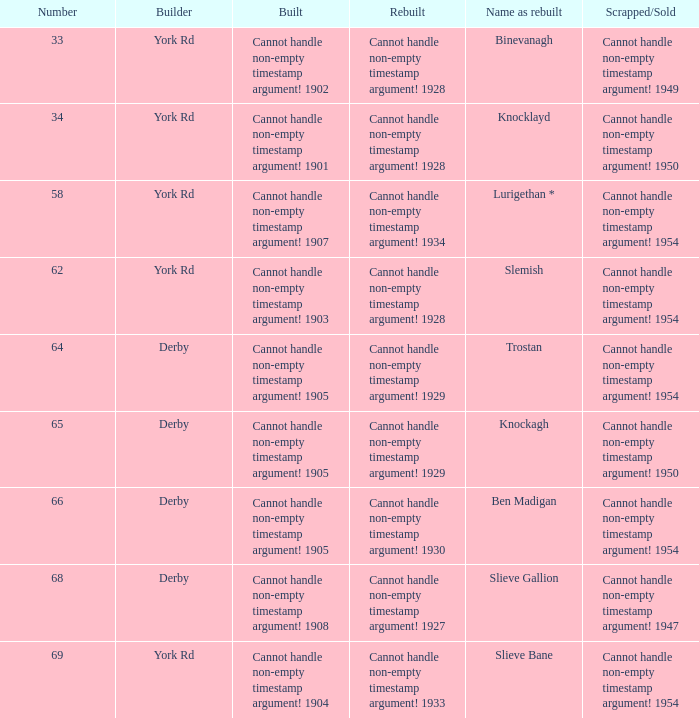Which Scrapped/Sold has a Builder of derby, and a Name as rebuilt of ben madigan? Cannot handle non-empty timestamp argument! 1954. 